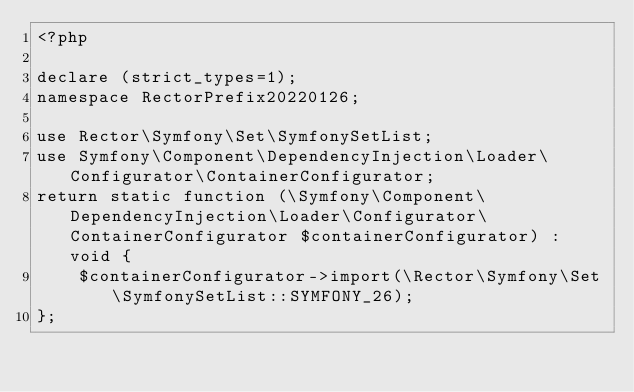Convert code to text. <code><loc_0><loc_0><loc_500><loc_500><_PHP_><?php

declare (strict_types=1);
namespace RectorPrefix20220126;

use Rector\Symfony\Set\SymfonySetList;
use Symfony\Component\DependencyInjection\Loader\Configurator\ContainerConfigurator;
return static function (\Symfony\Component\DependencyInjection\Loader\Configurator\ContainerConfigurator $containerConfigurator) : void {
    $containerConfigurator->import(\Rector\Symfony\Set\SymfonySetList::SYMFONY_26);
};
</code> 